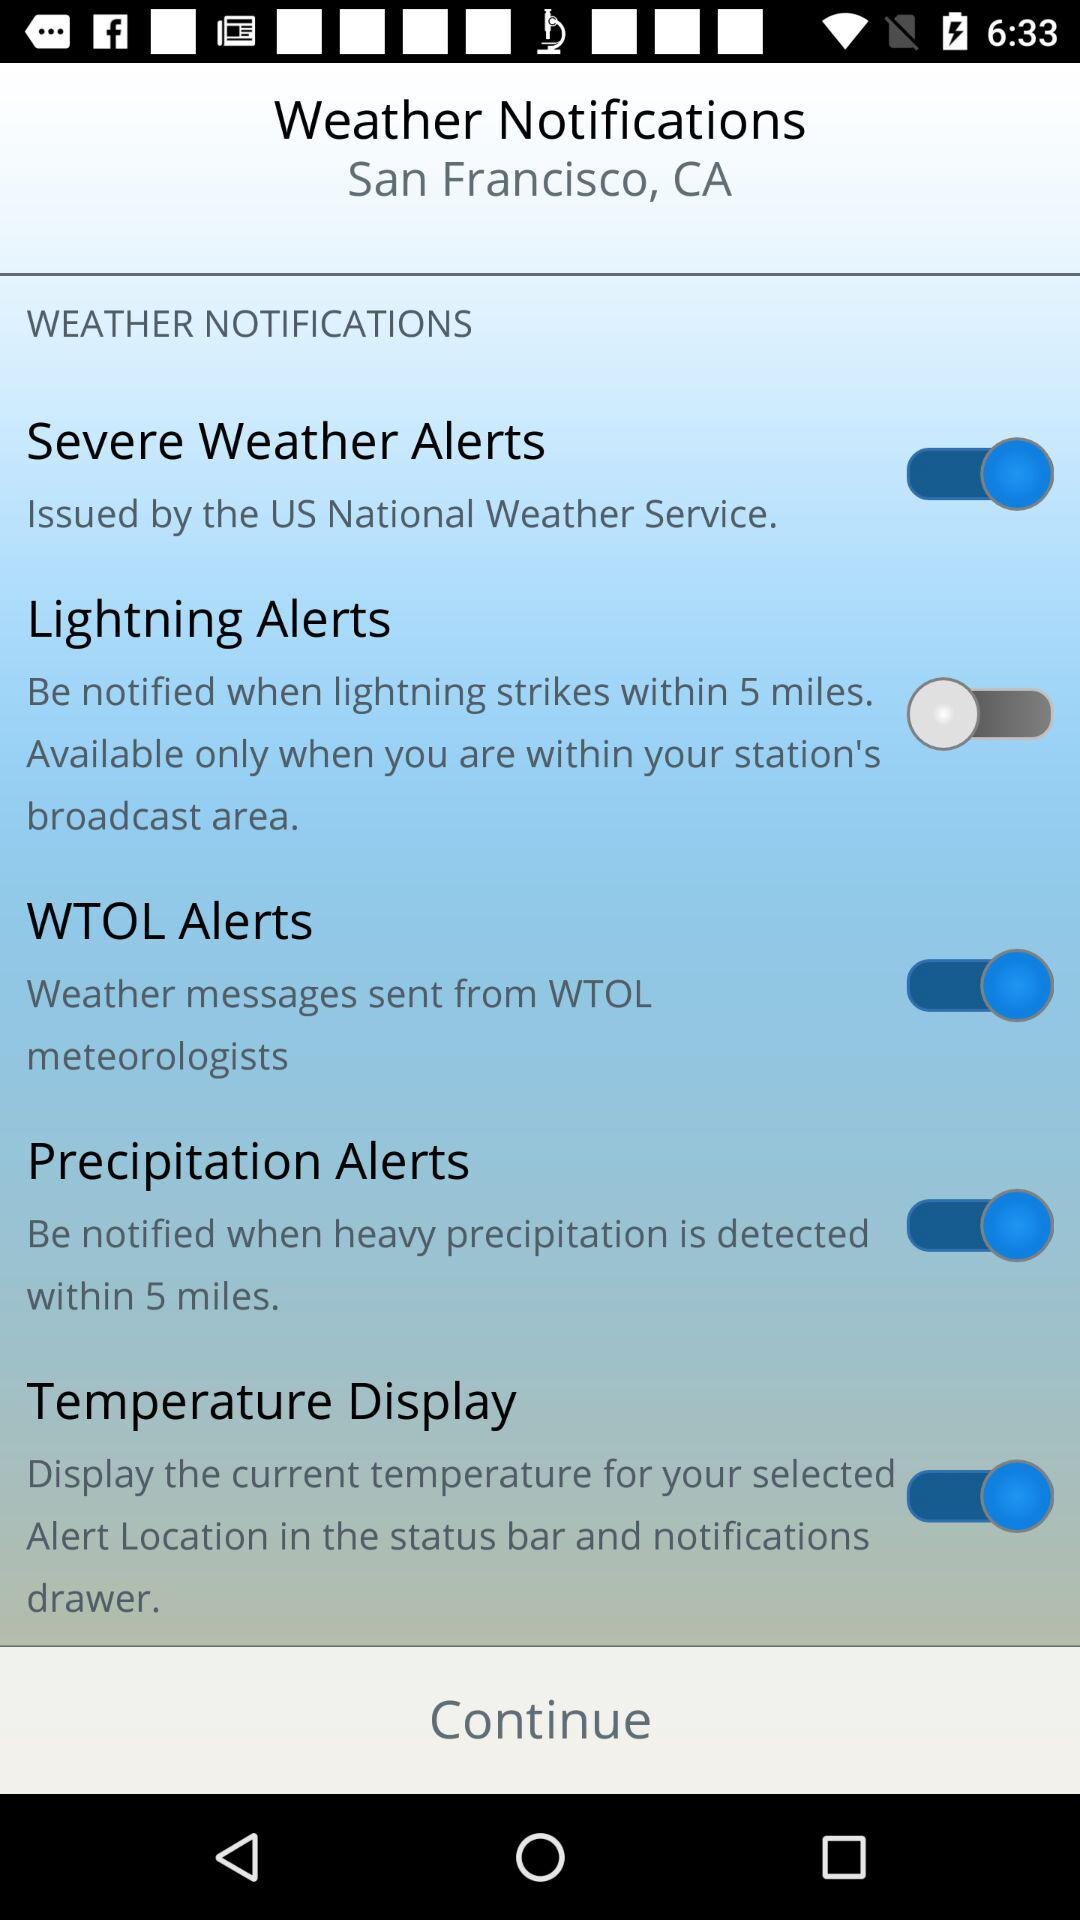What is the status of the "Lightning Alerts"? The status of the "Lightning Alerts" is "off". 